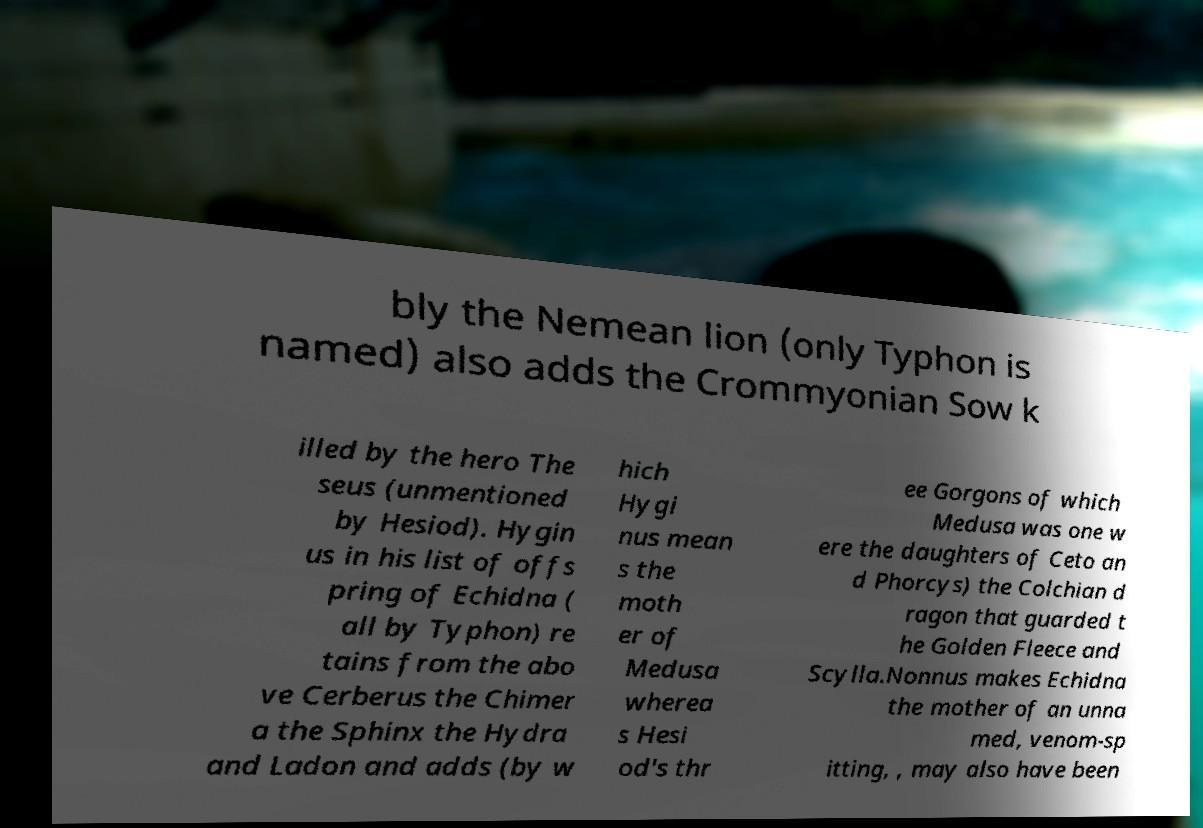I need the written content from this picture converted into text. Can you do that? bly the Nemean lion (only Typhon is named) also adds the Crommyonian Sow k illed by the hero The seus (unmentioned by Hesiod). Hygin us in his list of offs pring of Echidna ( all by Typhon) re tains from the abo ve Cerberus the Chimer a the Sphinx the Hydra and Ladon and adds (by w hich Hygi nus mean s the moth er of Medusa wherea s Hesi od's thr ee Gorgons of which Medusa was one w ere the daughters of Ceto an d Phorcys) the Colchian d ragon that guarded t he Golden Fleece and Scylla.Nonnus makes Echidna the mother of an unna med, venom-sp itting, , may also have been 